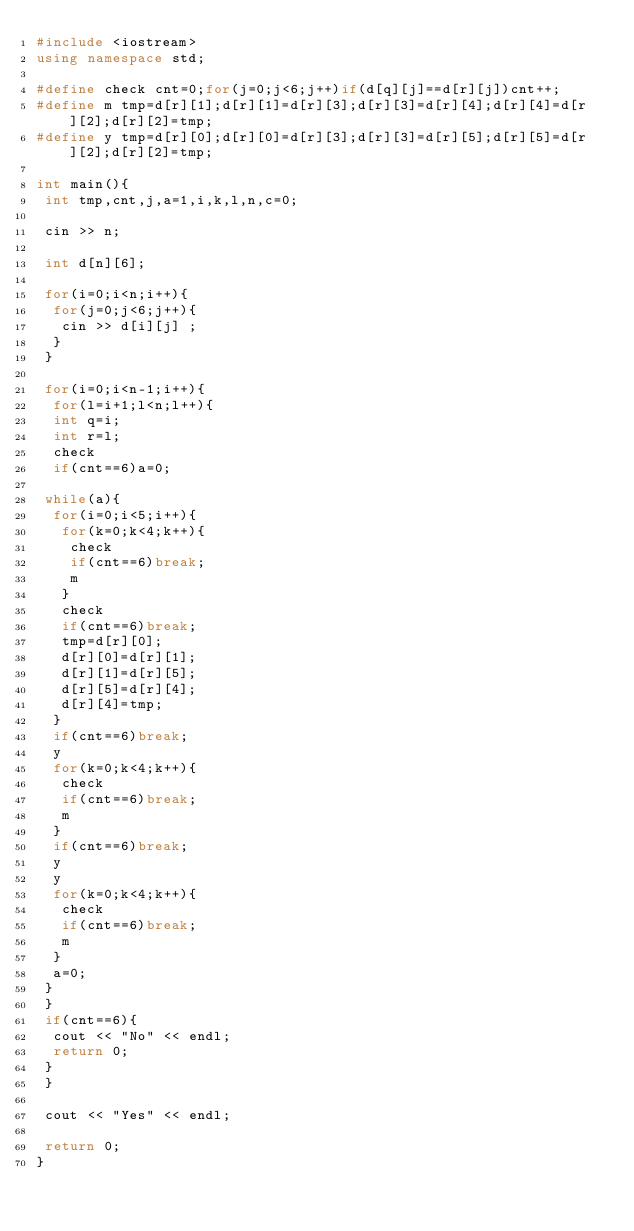<code> <loc_0><loc_0><loc_500><loc_500><_C++_>#include <iostream>
using namespace std;

#define check cnt=0;for(j=0;j<6;j++)if(d[q][j]==d[r][j])cnt++;
#define m tmp=d[r][1];d[r][1]=d[r][3];d[r][3]=d[r][4];d[r][4]=d[r][2];d[r][2]=tmp;
#define y tmp=d[r][0];d[r][0]=d[r][3];d[r][3]=d[r][5];d[r][5]=d[r][2];d[r][2]=tmp;

int main(){
 int tmp,cnt,j,a=1,i,k,l,n,c=0;

 cin >> n;

 int d[n][6];

 for(i=0;i<n;i++){
  for(j=0;j<6;j++){
   cin >> d[i][j] ;
  }
 }

 for(i=0;i<n-1;i++){
  for(l=i+1;l<n;l++){
  int q=i;
  int r=l;
  check
  if(cnt==6)a=0;

 while(a){
  for(i=0;i<5;i++){
   for(k=0;k<4;k++){
    check
    if(cnt==6)break;
    m
   }
   check
   if(cnt==6)break;
   tmp=d[r][0];
   d[r][0]=d[r][1];
   d[r][1]=d[r][5];
   d[r][5]=d[r][4];
   d[r][4]=tmp;
  }
  if(cnt==6)break;
  y
  for(k=0;k<4;k++){
   check
   if(cnt==6)break;
   m
  }
  if(cnt==6)break;
  y
  y
  for(k=0;k<4;k++){
   check
   if(cnt==6)break;
   m
  }
  a=0;
 }
 }
 if(cnt==6){
  cout << "No" << endl;
  return 0; 
 }
 }

 cout << "Yes" << endl;

 return 0;
}</code> 